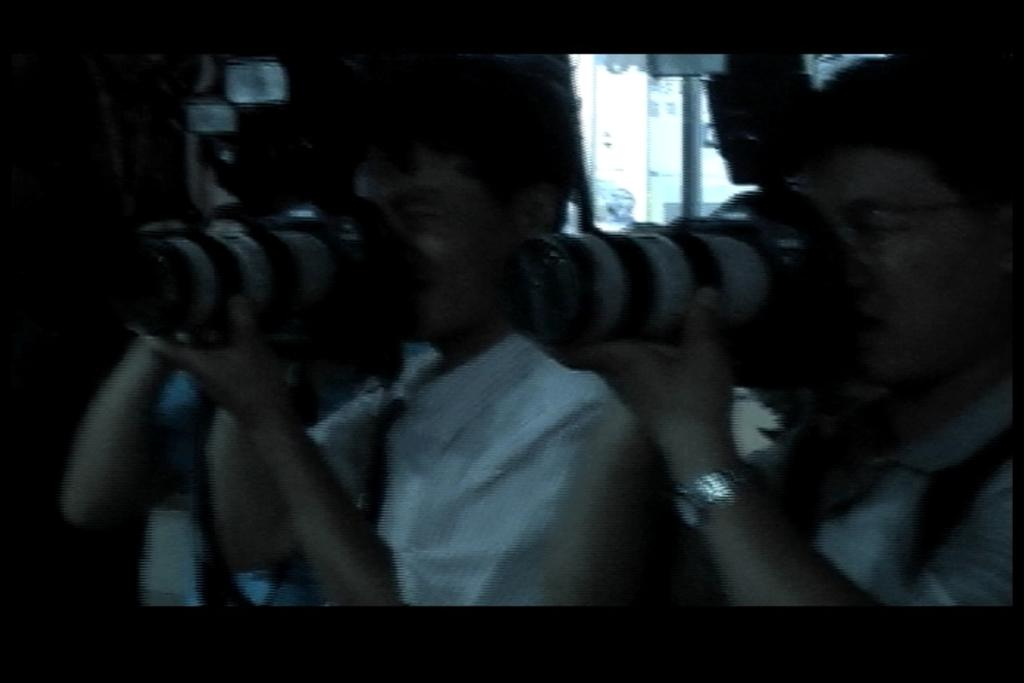How many people are in the image? There are two persons in the image. What are the persons holding in their hands? Both persons are holding cameras with their hands. What type of drug is the person on the left taking in the image? There is no indication of any drug in the image; the persons are holding cameras. 